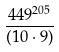<formula> <loc_0><loc_0><loc_500><loc_500>\frac { 4 4 9 ^ { 2 0 5 } } { ( 1 0 \cdot 9 ) }</formula> 